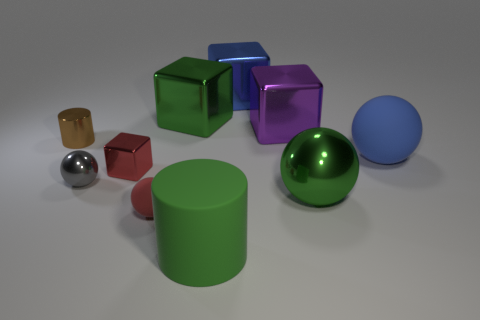Subtract 1 cubes. How many cubes are left? 3 Subtract all cubes. How many objects are left? 6 Subtract all large cyan metal things. Subtract all big blue objects. How many objects are left? 8 Add 4 big matte balls. How many big matte balls are left? 5 Add 5 red matte objects. How many red matte objects exist? 6 Subtract 1 blue balls. How many objects are left? 9 